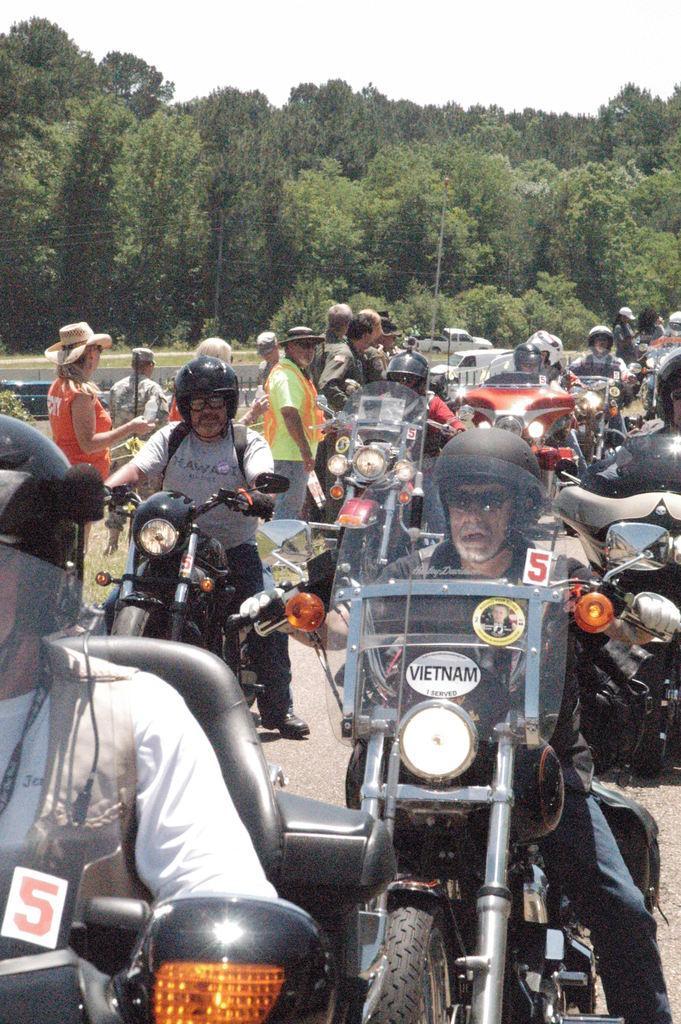Describe this image in one or two sentences. In this image I see lot of people on the bikes and few people standing over here. In the background I see the trees. 